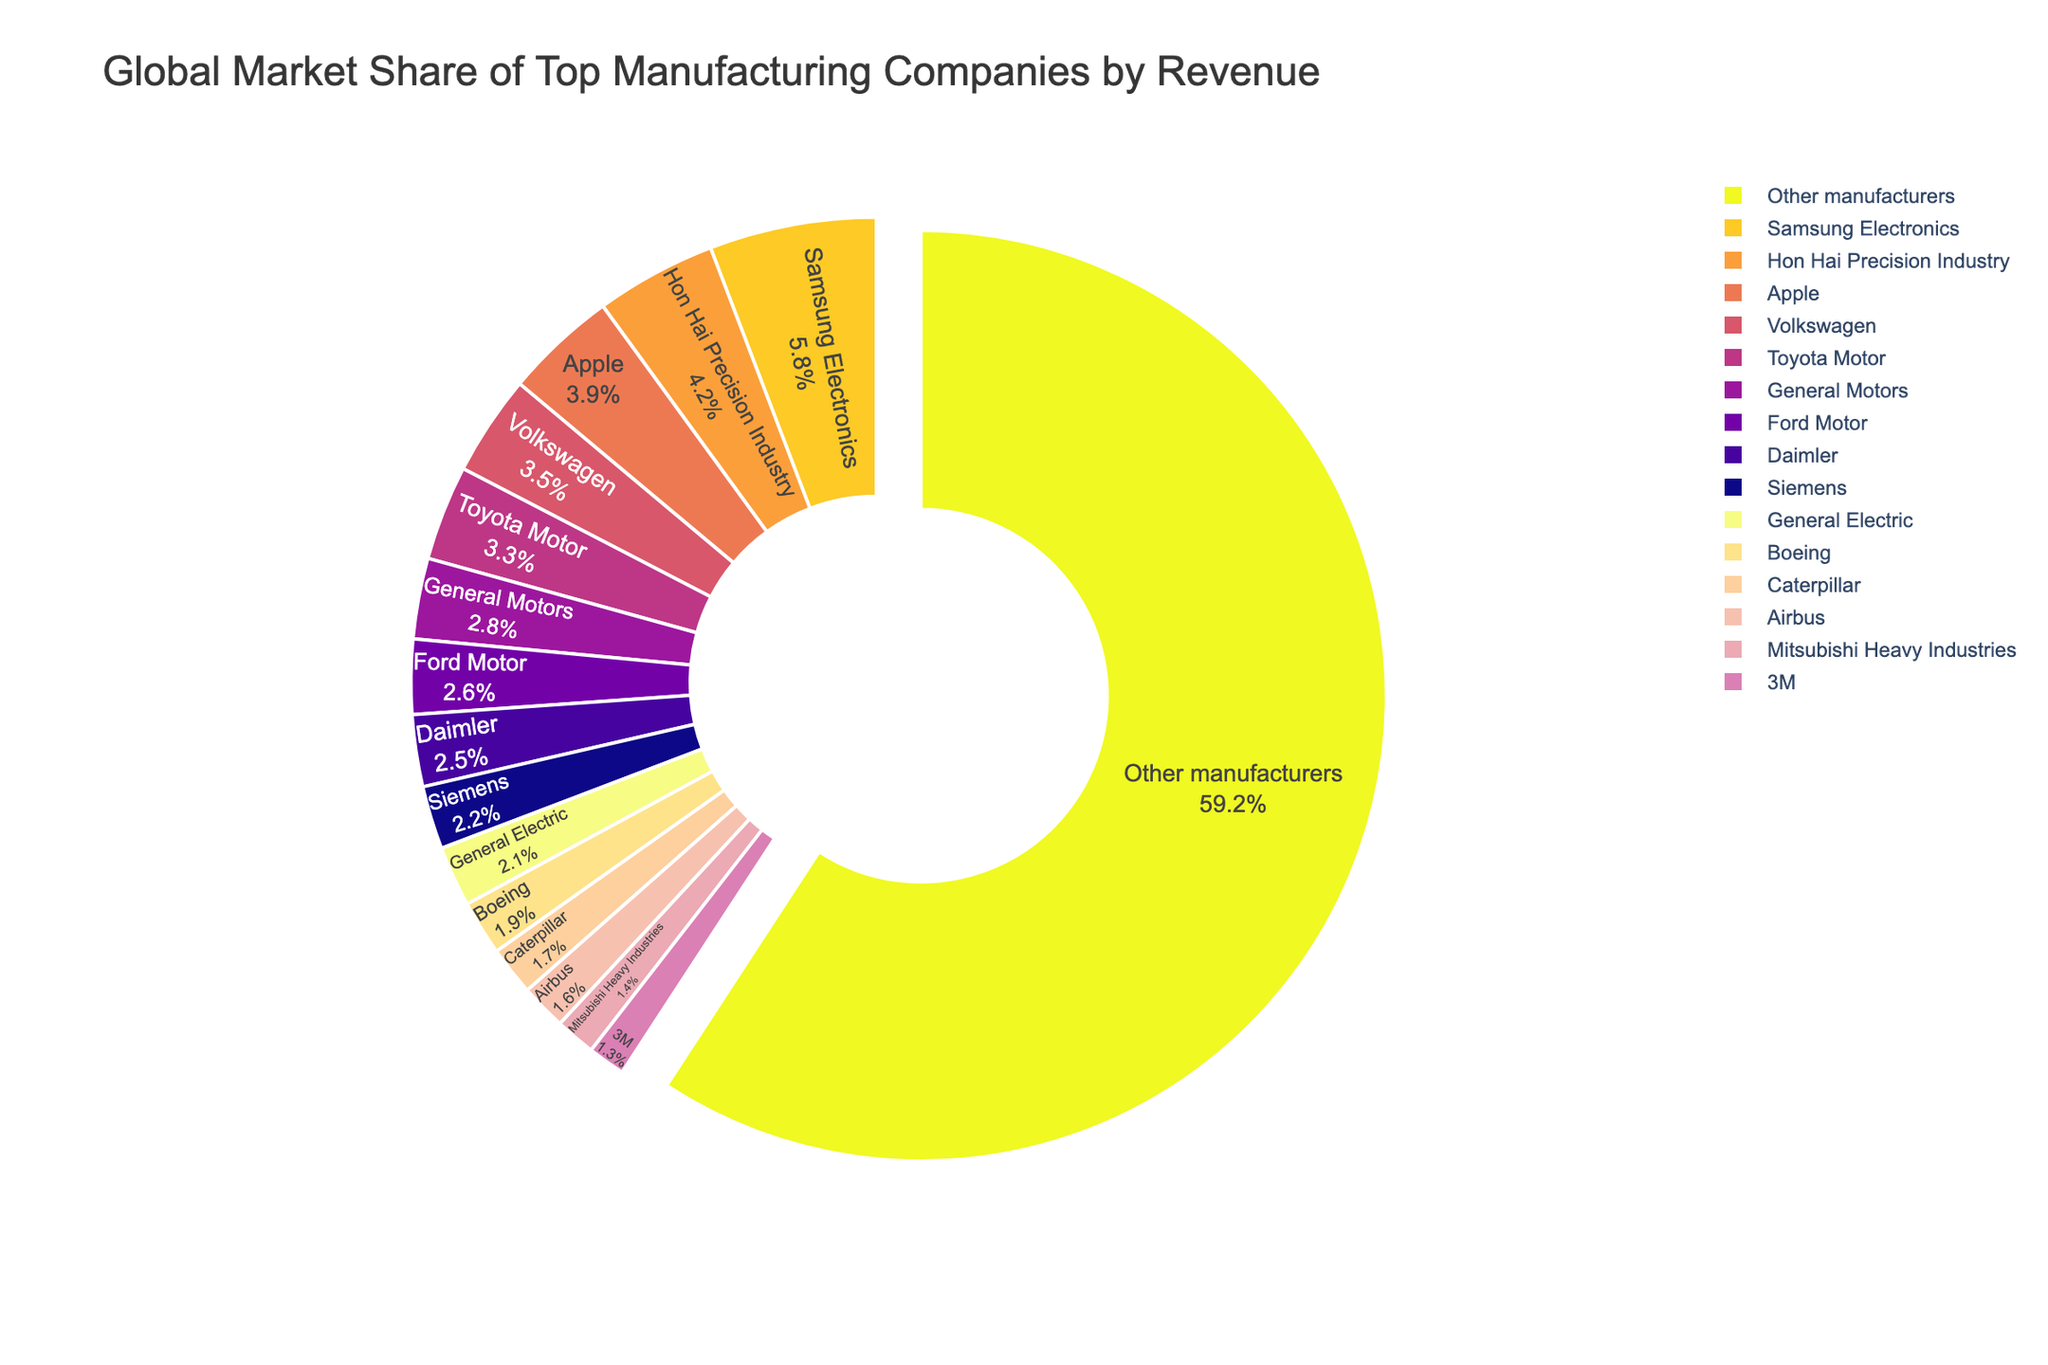What is the total market share of the top three companies? To find the total market share of the top three companies, sum their individual market shares. Samsung Electronics has a market share of 5.8%, Hon Hai Precision Industry has 4.2%, and Apple has 3.9%. Adding these together gives 5.8% + 4.2% + 3.9% = 13.9%.
Answer: 13.9% Which company has a larger market share, Volkswagen or Ford Motor? Compare the market shares of Volkswagen and Ford Motor. Volkswagen has a market share of 3.5%, while Ford Motor has a market share of 2.6%. Since 3.5% is greater than 2.6%, Volkswagen has a larger market share.
Answer: Volkswagen What is the combined market share of the Japanese companies (Toyota Motor and Mitsubishi Heavy Industries)? Add the market shares of Toyota Motor and Mitsubishi Heavy Industries. Toyota Motor holds 3.3% and Mitsubishi Heavy Industries holds 1.4%. Therefore, the combined market share is 3.3% + 1.4% = 4.7%.
Answer: 4.7% How many companies have a market share greater than 3%? Identify the companies with a market share greater than 3%. Samsung Electronics (5.8%), Hon Hai Precision Industry (4.2%), Apple (3.9%), Volkswagen (3.5%), and Toyota Motor (3.3%) all have market shares greater than 3%. There are 5 such companies.
Answer: 5 What is the market share difference between General Motors and Airbus? Subtract the market share of Airbus from that of General Motors. General Motors has a market share of 2.8%, and Airbus has a market share of 1.6%. The difference is 2.8% - 1.6% = 1.2%.
Answer: 1.2% What fraction of the total market share is held by 'Other manufacturers'? 'Other manufacturers' have a market share of 59.2%. Since the pie chart represents the whole (i.e., 100%), the fraction is 59.2 out of 100. This can be expressed as 59.2/100 or 59.2%.
Answer: 59.2% Which company holds just below a 2% market share? Identify the company with a market share just below 2%. Boeing has a market share of 1.9%, which is just below 2%.
Answer: Boeing Of the companies listed, which has the smallest market share? Scan for the smallest market share among the companies listed. 3M has the smallest market share at 1.3%.
Answer: 3M What is the average market share of the six companies with the smallest shares? Identify the six companies with the smallest market shares: General Electric (2.1%), Boeing (1.9%), Caterpillar (1.7%), Airbus (1.6%), Mitsubishi Heavy Industries (1.4%), and 3M (1.3%). Sum these shares: 2.1% + 1.9% + 1.7% + 1.6% + 1.4% + 1.3% = 10%. Divide by 6 to get the average: 10%/6 ≈ 1.67%.
Answer: ≈ 1.67% Which company's market share is visually the largest non-blue shade in the pie chart? The largest non-blue shade in the pie chart corresponds to Samsung Electronics, which has the largest market share among the companies listed at 5.8%.
Answer: Samsung Electronics 